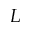Convert formula to latex. <formula><loc_0><loc_0><loc_500><loc_500>L</formula> 